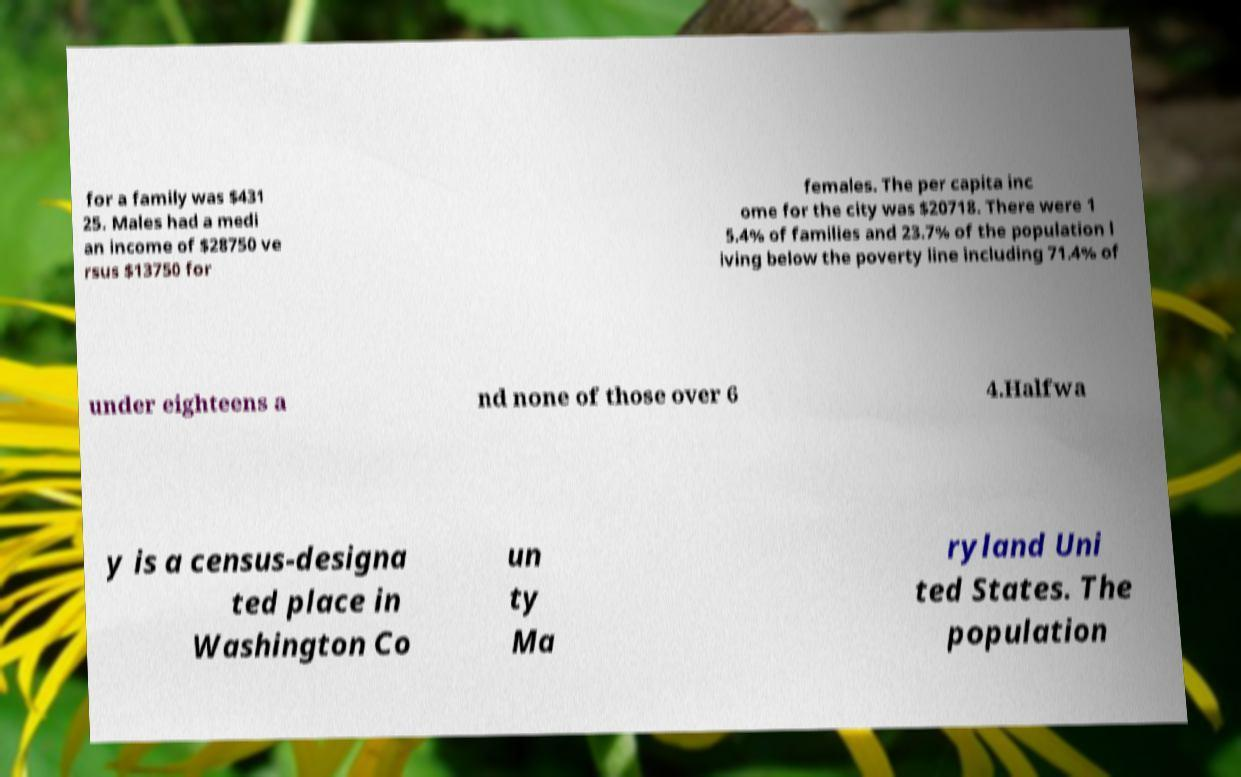What messages or text are displayed in this image? I need them in a readable, typed format. for a family was $431 25. Males had a medi an income of $28750 ve rsus $13750 for females. The per capita inc ome for the city was $20718. There were 1 5.4% of families and 23.7% of the population l iving below the poverty line including 71.4% of under eighteens a nd none of those over 6 4.Halfwa y is a census-designa ted place in Washington Co un ty Ma ryland Uni ted States. The population 